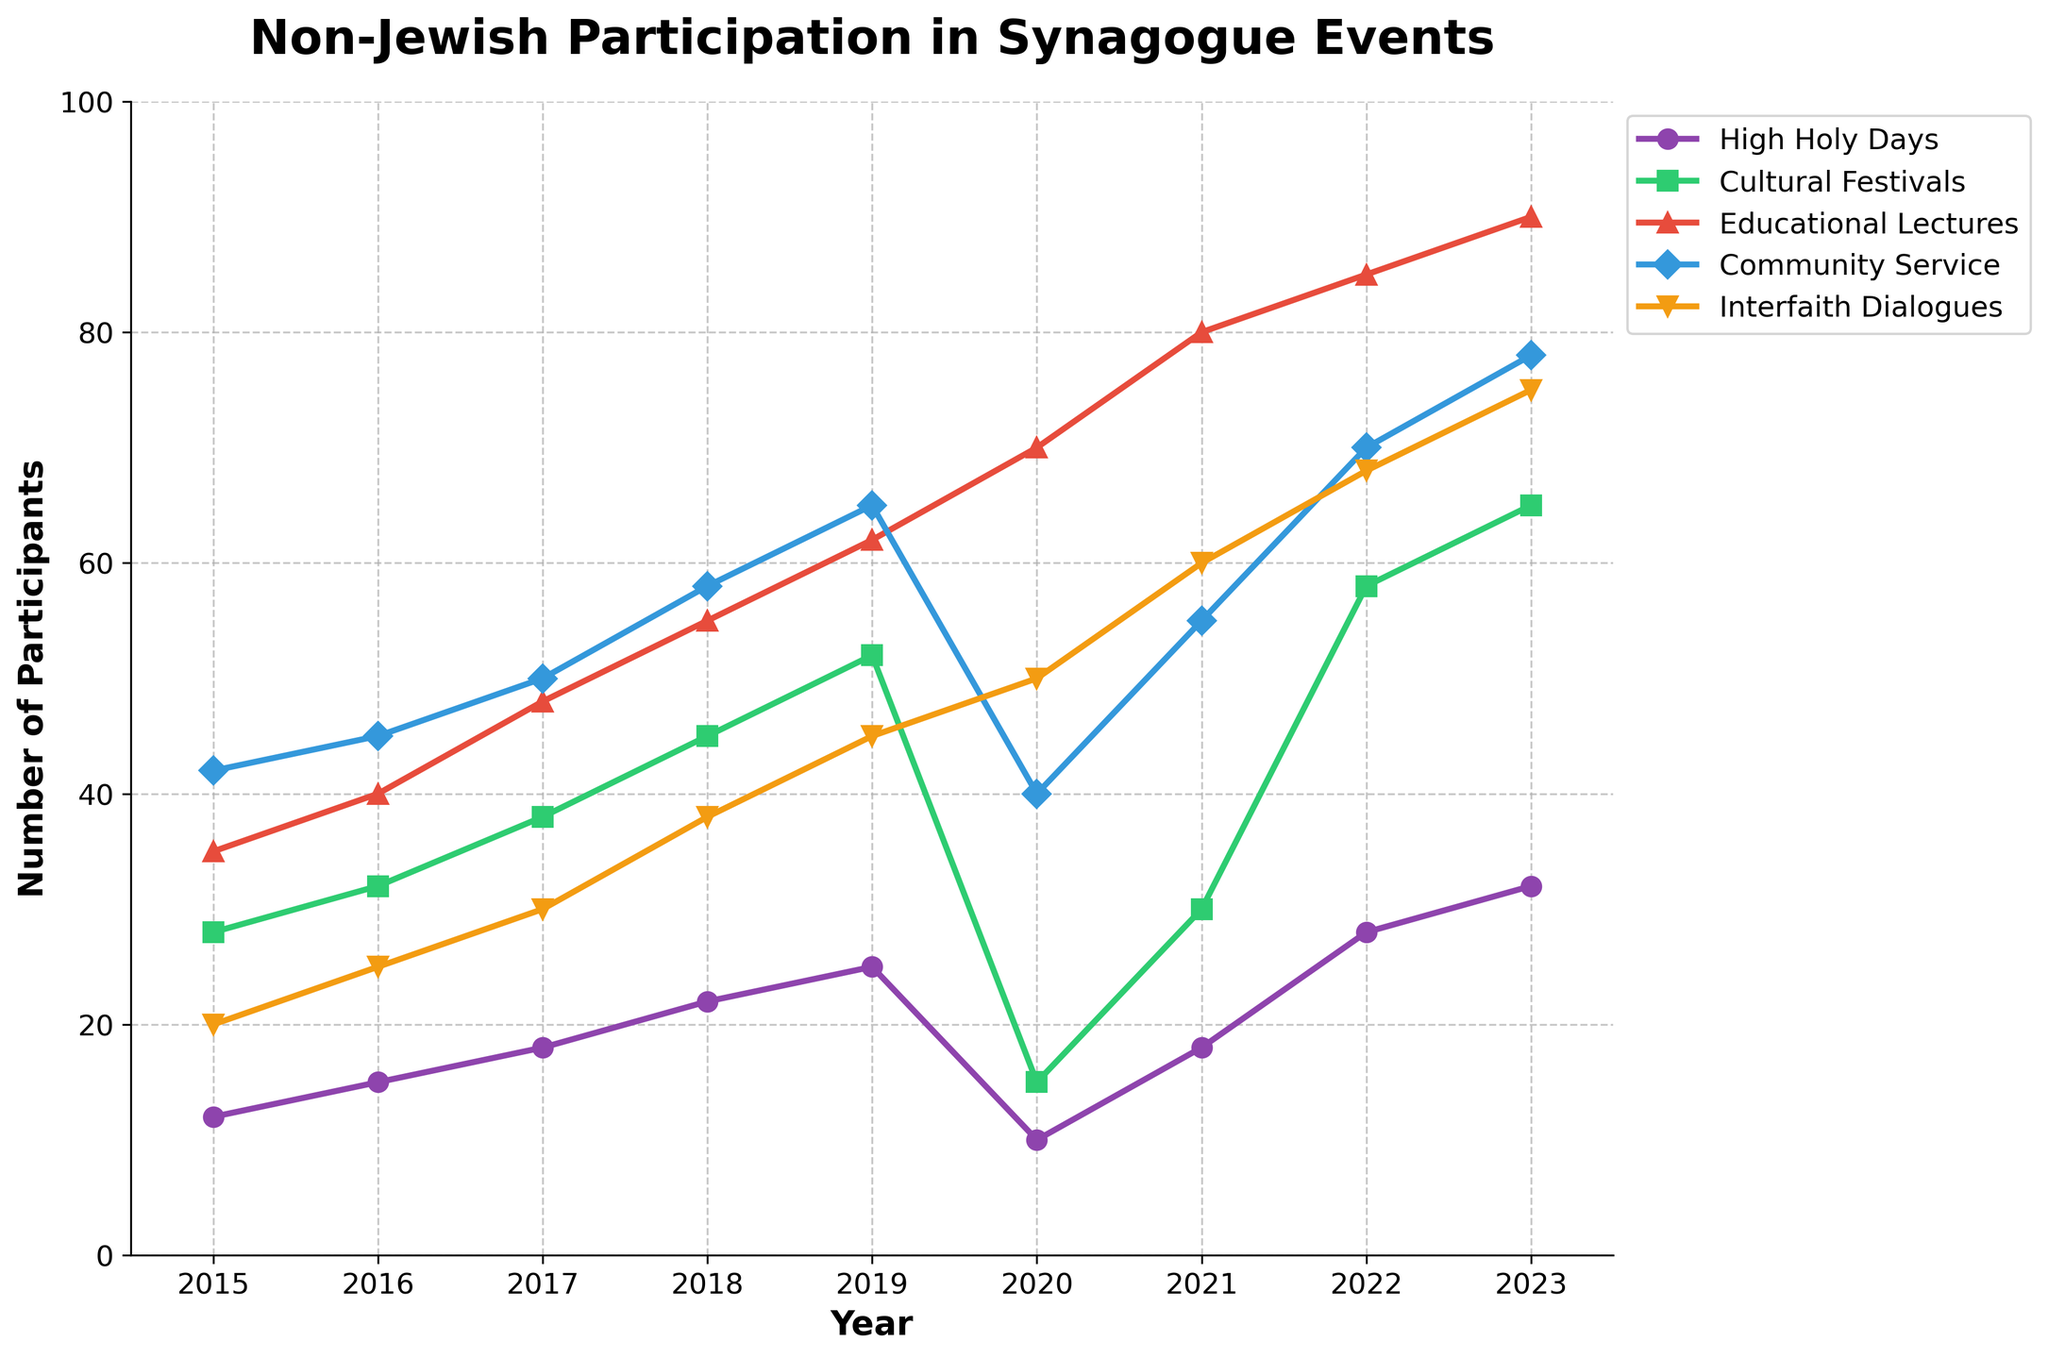What is the overall trend of non-Jewish participation in Educational Lectures from 2015 to 2023? From 2015 to 2019, the participation in Educational Lectures increased steadily from 35 to 62. There was a significant increase from 2020 onwards, despite a temporary dip in 2020. Over the entire period, there is an upward trend.
Answer: Upward trend Which event type saw the most significant decline in participation in 2020? The High Holy Days saw the most noticeable decline in participation from 25 in 2019 to 10 in 2020. Comparing the drop across all events, this is the steepest decline.
Answer: High Holy Days By how many participants did the average number of attendees at Community Service events increase from 2016 to 2023? In 2016, there were 45 participants, and in 2023, there were 78. The increase is 78 - 45 = 33.
Answer: 33 Compare the number of participants in Cultural Festivals and Interfaith Dialogues in 2022. Which one had more participants and by how much? In 2022, Cultural Festivals had 58 participants, while Interfaith Dialogues had 68 participants. The difference is 68 - 58 = 10, meaning Interfaith Dialogues had 10 more participants.
Answer: Interfaith Dialogues by 10 What was the total non-Jewish participation in all event types in the year 2018? In 2018, the numbers are 22 (High Holy Days) + 45 (Cultural Festivals) + 55 (Educational Lectures) + 58 (Community Service) + 38 (Interfaith Dialogues). The total is 218.
Answer: 218 Identify the year with the highest participation in Interfaith Dialogues and specify the number of participants. The year with the highest participation in Interfaith Dialogues is 2023, with 75 participants.
Answer: 2023 with 75 In which year did the participation in Community Service events overtake that of Educational Lectures, and by how much? In 2019, Community Service had 65 participants, surpassing Educational Lectures with 62. This is an overtake by 3 participants.
Answer: 2019 by 3 What is the difference in the number of participants for the High Holy Days between the highest and lowest recorded years? The highest number of participants for the High Holy Days was 32 in 2023, and the lowest was 10 in 2020. The difference is 32 - 10 = 22.
Answer: 22 If we sum the participation numbers for each year, which year has the second-lowest overall participation? Calculating the sum for each year reveals that 2020, with a total of 185 participants, is the second-lowest after 2015.
Answer: 2020 